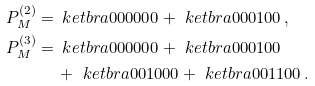Convert formula to latex. <formula><loc_0><loc_0><loc_500><loc_500>P _ { M } ^ { ( 2 ) } = \, & \ k e t b r a { 0 0 0 0 0 0 } + \ k e t b r a { 0 0 0 1 0 0 } \, , \\ P _ { M } ^ { ( 3 ) } = \, & \ k e t b r a { 0 0 0 0 0 0 } + \ k e t b r a { 0 0 0 1 0 0 } \\ & + \ k e t b r a { 0 0 1 0 0 0 } + \ k e t b r a { 0 0 1 1 0 0 } \, .</formula> 